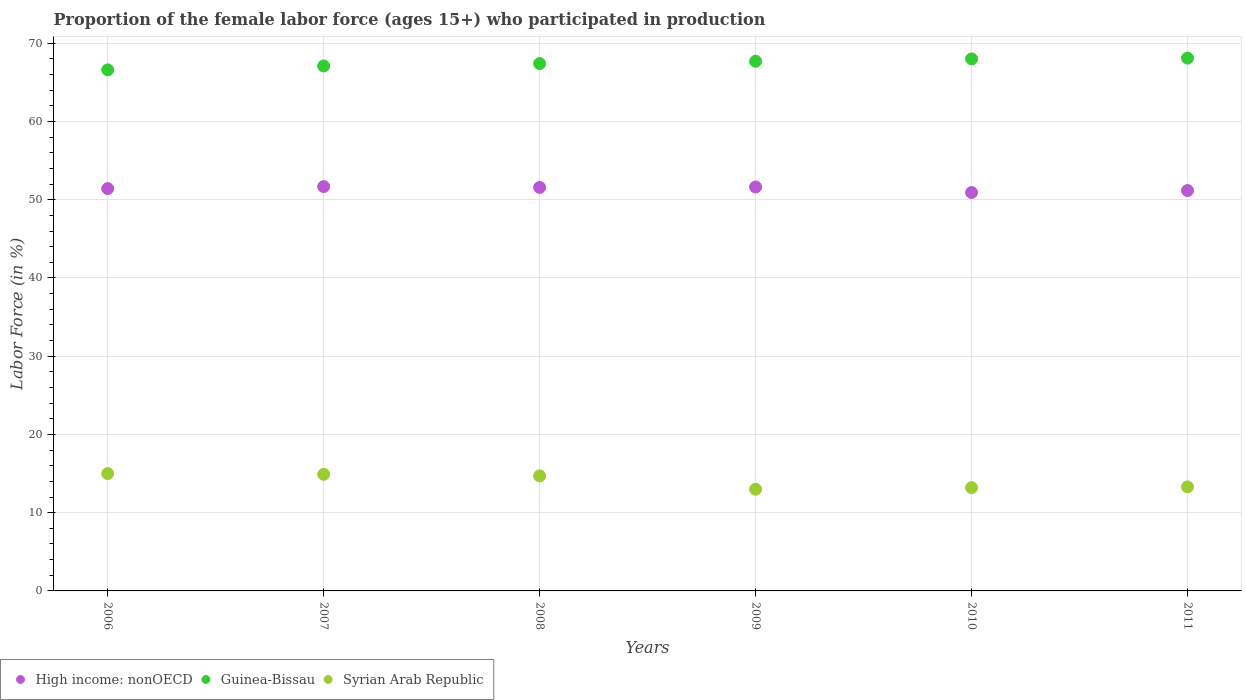Is the number of dotlines equal to the number of legend labels?
Ensure brevity in your answer.  Yes. What is the proportion of the female labor force who participated in production in Syrian Arab Republic in 2011?
Provide a short and direct response. 13.3. Across all years, what is the maximum proportion of the female labor force who participated in production in Syrian Arab Republic?
Give a very brief answer. 15. Across all years, what is the minimum proportion of the female labor force who participated in production in High income: nonOECD?
Offer a terse response. 50.92. In which year was the proportion of the female labor force who participated in production in Syrian Arab Republic maximum?
Your answer should be very brief. 2006. In which year was the proportion of the female labor force who participated in production in Guinea-Bissau minimum?
Give a very brief answer. 2006. What is the total proportion of the female labor force who participated in production in Syrian Arab Republic in the graph?
Your answer should be compact. 84.1. What is the difference between the proportion of the female labor force who participated in production in High income: nonOECD in 2007 and that in 2010?
Provide a succinct answer. 0.76. What is the difference between the proportion of the female labor force who participated in production in Syrian Arab Republic in 2006 and the proportion of the female labor force who participated in production in High income: nonOECD in 2008?
Offer a very short reply. -36.57. What is the average proportion of the female labor force who participated in production in High income: nonOECD per year?
Your answer should be compact. 51.4. In the year 2007, what is the difference between the proportion of the female labor force who participated in production in Guinea-Bissau and proportion of the female labor force who participated in production in Syrian Arab Republic?
Provide a succinct answer. 52.2. What is the ratio of the proportion of the female labor force who participated in production in High income: nonOECD in 2006 to that in 2010?
Keep it short and to the point. 1.01. Is the proportion of the female labor force who participated in production in High income: nonOECD in 2007 less than that in 2011?
Offer a terse response. No. What is the difference between the highest and the second highest proportion of the female labor force who participated in production in High income: nonOECD?
Provide a short and direct response. 0.05. What is the difference between the highest and the lowest proportion of the female labor force who participated in production in Guinea-Bissau?
Ensure brevity in your answer.  1.5. In how many years, is the proportion of the female labor force who participated in production in High income: nonOECD greater than the average proportion of the female labor force who participated in production in High income: nonOECD taken over all years?
Keep it short and to the point. 4. Is the sum of the proportion of the female labor force who participated in production in Syrian Arab Republic in 2008 and 2009 greater than the maximum proportion of the female labor force who participated in production in High income: nonOECD across all years?
Offer a terse response. No. Is it the case that in every year, the sum of the proportion of the female labor force who participated in production in High income: nonOECD and proportion of the female labor force who participated in production in Syrian Arab Republic  is greater than the proportion of the female labor force who participated in production in Guinea-Bissau?
Your answer should be compact. No. Does the proportion of the female labor force who participated in production in High income: nonOECD monotonically increase over the years?
Make the answer very short. No. Is the proportion of the female labor force who participated in production in High income: nonOECD strictly greater than the proportion of the female labor force who participated in production in Guinea-Bissau over the years?
Keep it short and to the point. No. What is the difference between two consecutive major ticks on the Y-axis?
Offer a very short reply. 10. Are the values on the major ticks of Y-axis written in scientific E-notation?
Offer a terse response. No. Where does the legend appear in the graph?
Offer a very short reply. Bottom left. How many legend labels are there?
Provide a succinct answer. 3. What is the title of the graph?
Make the answer very short. Proportion of the female labor force (ages 15+) who participated in production. Does "Botswana" appear as one of the legend labels in the graph?
Give a very brief answer. No. What is the Labor Force (in %) in High income: nonOECD in 2006?
Offer a terse response. 51.42. What is the Labor Force (in %) of Guinea-Bissau in 2006?
Make the answer very short. 66.6. What is the Labor Force (in %) of Syrian Arab Republic in 2006?
Provide a short and direct response. 15. What is the Labor Force (in %) of High income: nonOECD in 2007?
Keep it short and to the point. 51.68. What is the Labor Force (in %) of Guinea-Bissau in 2007?
Keep it short and to the point. 67.1. What is the Labor Force (in %) of Syrian Arab Republic in 2007?
Ensure brevity in your answer.  14.9. What is the Labor Force (in %) of High income: nonOECD in 2008?
Keep it short and to the point. 51.57. What is the Labor Force (in %) in Guinea-Bissau in 2008?
Ensure brevity in your answer.  67.4. What is the Labor Force (in %) of Syrian Arab Republic in 2008?
Provide a short and direct response. 14.7. What is the Labor Force (in %) in High income: nonOECD in 2009?
Your answer should be very brief. 51.63. What is the Labor Force (in %) of Guinea-Bissau in 2009?
Provide a short and direct response. 67.7. What is the Labor Force (in %) of High income: nonOECD in 2010?
Your answer should be compact. 50.92. What is the Labor Force (in %) in Guinea-Bissau in 2010?
Make the answer very short. 68. What is the Labor Force (in %) of Syrian Arab Republic in 2010?
Provide a short and direct response. 13.2. What is the Labor Force (in %) of High income: nonOECD in 2011?
Your response must be concise. 51.18. What is the Labor Force (in %) of Guinea-Bissau in 2011?
Make the answer very short. 68.1. What is the Labor Force (in %) in Syrian Arab Republic in 2011?
Offer a terse response. 13.3. Across all years, what is the maximum Labor Force (in %) of High income: nonOECD?
Ensure brevity in your answer.  51.68. Across all years, what is the maximum Labor Force (in %) of Guinea-Bissau?
Your response must be concise. 68.1. Across all years, what is the maximum Labor Force (in %) in Syrian Arab Republic?
Offer a terse response. 15. Across all years, what is the minimum Labor Force (in %) of High income: nonOECD?
Provide a short and direct response. 50.92. Across all years, what is the minimum Labor Force (in %) in Guinea-Bissau?
Your response must be concise. 66.6. Across all years, what is the minimum Labor Force (in %) in Syrian Arab Republic?
Keep it short and to the point. 13. What is the total Labor Force (in %) in High income: nonOECD in the graph?
Offer a very short reply. 308.4. What is the total Labor Force (in %) of Guinea-Bissau in the graph?
Provide a succinct answer. 404.9. What is the total Labor Force (in %) of Syrian Arab Republic in the graph?
Ensure brevity in your answer.  84.1. What is the difference between the Labor Force (in %) in High income: nonOECD in 2006 and that in 2007?
Give a very brief answer. -0.26. What is the difference between the Labor Force (in %) of Guinea-Bissau in 2006 and that in 2007?
Keep it short and to the point. -0.5. What is the difference between the Labor Force (in %) in High income: nonOECD in 2006 and that in 2008?
Give a very brief answer. -0.15. What is the difference between the Labor Force (in %) of Syrian Arab Republic in 2006 and that in 2008?
Provide a succinct answer. 0.3. What is the difference between the Labor Force (in %) of High income: nonOECD in 2006 and that in 2009?
Ensure brevity in your answer.  -0.2. What is the difference between the Labor Force (in %) in Syrian Arab Republic in 2006 and that in 2009?
Keep it short and to the point. 2. What is the difference between the Labor Force (in %) in High income: nonOECD in 2006 and that in 2010?
Offer a terse response. 0.5. What is the difference between the Labor Force (in %) of Syrian Arab Republic in 2006 and that in 2010?
Give a very brief answer. 1.8. What is the difference between the Labor Force (in %) in High income: nonOECD in 2006 and that in 2011?
Your response must be concise. 0.25. What is the difference between the Labor Force (in %) of Guinea-Bissau in 2006 and that in 2011?
Your answer should be very brief. -1.5. What is the difference between the Labor Force (in %) of Syrian Arab Republic in 2006 and that in 2011?
Offer a terse response. 1.7. What is the difference between the Labor Force (in %) in High income: nonOECD in 2007 and that in 2008?
Offer a very short reply. 0.11. What is the difference between the Labor Force (in %) of Guinea-Bissau in 2007 and that in 2008?
Give a very brief answer. -0.3. What is the difference between the Labor Force (in %) in High income: nonOECD in 2007 and that in 2009?
Your answer should be very brief. 0.05. What is the difference between the Labor Force (in %) in High income: nonOECD in 2007 and that in 2010?
Offer a terse response. 0.76. What is the difference between the Labor Force (in %) in High income: nonOECD in 2007 and that in 2011?
Give a very brief answer. 0.5. What is the difference between the Labor Force (in %) of High income: nonOECD in 2008 and that in 2009?
Provide a short and direct response. -0.06. What is the difference between the Labor Force (in %) of Syrian Arab Republic in 2008 and that in 2009?
Keep it short and to the point. 1.7. What is the difference between the Labor Force (in %) of High income: nonOECD in 2008 and that in 2010?
Offer a terse response. 0.65. What is the difference between the Labor Force (in %) in Syrian Arab Republic in 2008 and that in 2010?
Provide a short and direct response. 1.5. What is the difference between the Labor Force (in %) in High income: nonOECD in 2008 and that in 2011?
Your answer should be very brief. 0.4. What is the difference between the Labor Force (in %) in Syrian Arab Republic in 2008 and that in 2011?
Provide a short and direct response. 1.4. What is the difference between the Labor Force (in %) of High income: nonOECD in 2009 and that in 2010?
Provide a short and direct response. 0.71. What is the difference between the Labor Force (in %) of Guinea-Bissau in 2009 and that in 2010?
Provide a short and direct response. -0.3. What is the difference between the Labor Force (in %) in Syrian Arab Republic in 2009 and that in 2010?
Ensure brevity in your answer.  -0.2. What is the difference between the Labor Force (in %) of High income: nonOECD in 2009 and that in 2011?
Give a very brief answer. 0.45. What is the difference between the Labor Force (in %) in Syrian Arab Republic in 2009 and that in 2011?
Your response must be concise. -0.3. What is the difference between the Labor Force (in %) of High income: nonOECD in 2010 and that in 2011?
Ensure brevity in your answer.  -0.25. What is the difference between the Labor Force (in %) of Guinea-Bissau in 2010 and that in 2011?
Offer a very short reply. -0.1. What is the difference between the Labor Force (in %) of Syrian Arab Republic in 2010 and that in 2011?
Make the answer very short. -0.1. What is the difference between the Labor Force (in %) of High income: nonOECD in 2006 and the Labor Force (in %) of Guinea-Bissau in 2007?
Provide a short and direct response. -15.68. What is the difference between the Labor Force (in %) of High income: nonOECD in 2006 and the Labor Force (in %) of Syrian Arab Republic in 2007?
Keep it short and to the point. 36.52. What is the difference between the Labor Force (in %) in Guinea-Bissau in 2006 and the Labor Force (in %) in Syrian Arab Republic in 2007?
Offer a terse response. 51.7. What is the difference between the Labor Force (in %) of High income: nonOECD in 2006 and the Labor Force (in %) of Guinea-Bissau in 2008?
Your answer should be very brief. -15.98. What is the difference between the Labor Force (in %) in High income: nonOECD in 2006 and the Labor Force (in %) in Syrian Arab Republic in 2008?
Your answer should be compact. 36.72. What is the difference between the Labor Force (in %) of Guinea-Bissau in 2006 and the Labor Force (in %) of Syrian Arab Republic in 2008?
Your response must be concise. 51.9. What is the difference between the Labor Force (in %) of High income: nonOECD in 2006 and the Labor Force (in %) of Guinea-Bissau in 2009?
Ensure brevity in your answer.  -16.28. What is the difference between the Labor Force (in %) in High income: nonOECD in 2006 and the Labor Force (in %) in Syrian Arab Republic in 2009?
Make the answer very short. 38.42. What is the difference between the Labor Force (in %) in Guinea-Bissau in 2006 and the Labor Force (in %) in Syrian Arab Republic in 2009?
Provide a succinct answer. 53.6. What is the difference between the Labor Force (in %) of High income: nonOECD in 2006 and the Labor Force (in %) of Guinea-Bissau in 2010?
Your response must be concise. -16.58. What is the difference between the Labor Force (in %) in High income: nonOECD in 2006 and the Labor Force (in %) in Syrian Arab Republic in 2010?
Give a very brief answer. 38.22. What is the difference between the Labor Force (in %) in Guinea-Bissau in 2006 and the Labor Force (in %) in Syrian Arab Republic in 2010?
Offer a terse response. 53.4. What is the difference between the Labor Force (in %) of High income: nonOECD in 2006 and the Labor Force (in %) of Guinea-Bissau in 2011?
Ensure brevity in your answer.  -16.68. What is the difference between the Labor Force (in %) of High income: nonOECD in 2006 and the Labor Force (in %) of Syrian Arab Republic in 2011?
Make the answer very short. 38.12. What is the difference between the Labor Force (in %) in Guinea-Bissau in 2006 and the Labor Force (in %) in Syrian Arab Republic in 2011?
Your response must be concise. 53.3. What is the difference between the Labor Force (in %) in High income: nonOECD in 2007 and the Labor Force (in %) in Guinea-Bissau in 2008?
Your answer should be very brief. -15.72. What is the difference between the Labor Force (in %) in High income: nonOECD in 2007 and the Labor Force (in %) in Syrian Arab Republic in 2008?
Your response must be concise. 36.98. What is the difference between the Labor Force (in %) in Guinea-Bissau in 2007 and the Labor Force (in %) in Syrian Arab Republic in 2008?
Your response must be concise. 52.4. What is the difference between the Labor Force (in %) in High income: nonOECD in 2007 and the Labor Force (in %) in Guinea-Bissau in 2009?
Your answer should be very brief. -16.02. What is the difference between the Labor Force (in %) of High income: nonOECD in 2007 and the Labor Force (in %) of Syrian Arab Republic in 2009?
Offer a terse response. 38.68. What is the difference between the Labor Force (in %) of Guinea-Bissau in 2007 and the Labor Force (in %) of Syrian Arab Republic in 2009?
Make the answer very short. 54.1. What is the difference between the Labor Force (in %) in High income: nonOECD in 2007 and the Labor Force (in %) in Guinea-Bissau in 2010?
Provide a succinct answer. -16.32. What is the difference between the Labor Force (in %) of High income: nonOECD in 2007 and the Labor Force (in %) of Syrian Arab Republic in 2010?
Your answer should be very brief. 38.48. What is the difference between the Labor Force (in %) of Guinea-Bissau in 2007 and the Labor Force (in %) of Syrian Arab Republic in 2010?
Ensure brevity in your answer.  53.9. What is the difference between the Labor Force (in %) in High income: nonOECD in 2007 and the Labor Force (in %) in Guinea-Bissau in 2011?
Provide a short and direct response. -16.42. What is the difference between the Labor Force (in %) of High income: nonOECD in 2007 and the Labor Force (in %) of Syrian Arab Republic in 2011?
Your response must be concise. 38.38. What is the difference between the Labor Force (in %) of Guinea-Bissau in 2007 and the Labor Force (in %) of Syrian Arab Republic in 2011?
Your answer should be compact. 53.8. What is the difference between the Labor Force (in %) in High income: nonOECD in 2008 and the Labor Force (in %) in Guinea-Bissau in 2009?
Your response must be concise. -16.13. What is the difference between the Labor Force (in %) of High income: nonOECD in 2008 and the Labor Force (in %) of Syrian Arab Republic in 2009?
Provide a short and direct response. 38.57. What is the difference between the Labor Force (in %) of Guinea-Bissau in 2008 and the Labor Force (in %) of Syrian Arab Republic in 2009?
Provide a succinct answer. 54.4. What is the difference between the Labor Force (in %) of High income: nonOECD in 2008 and the Labor Force (in %) of Guinea-Bissau in 2010?
Offer a very short reply. -16.43. What is the difference between the Labor Force (in %) of High income: nonOECD in 2008 and the Labor Force (in %) of Syrian Arab Republic in 2010?
Give a very brief answer. 38.37. What is the difference between the Labor Force (in %) of Guinea-Bissau in 2008 and the Labor Force (in %) of Syrian Arab Republic in 2010?
Your answer should be compact. 54.2. What is the difference between the Labor Force (in %) of High income: nonOECD in 2008 and the Labor Force (in %) of Guinea-Bissau in 2011?
Make the answer very short. -16.53. What is the difference between the Labor Force (in %) of High income: nonOECD in 2008 and the Labor Force (in %) of Syrian Arab Republic in 2011?
Offer a terse response. 38.27. What is the difference between the Labor Force (in %) in Guinea-Bissau in 2008 and the Labor Force (in %) in Syrian Arab Republic in 2011?
Offer a terse response. 54.1. What is the difference between the Labor Force (in %) of High income: nonOECD in 2009 and the Labor Force (in %) of Guinea-Bissau in 2010?
Ensure brevity in your answer.  -16.37. What is the difference between the Labor Force (in %) of High income: nonOECD in 2009 and the Labor Force (in %) of Syrian Arab Republic in 2010?
Your answer should be compact. 38.43. What is the difference between the Labor Force (in %) in Guinea-Bissau in 2009 and the Labor Force (in %) in Syrian Arab Republic in 2010?
Your response must be concise. 54.5. What is the difference between the Labor Force (in %) in High income: nonOECD in 2009 and the Labor Force (in %) in Guinea-Bissau in 2011?
Give a very brief answer. -16.47. What is the difference between the Labor Force (in %) in High income: nonOECD in 2009 and the Labor Force (in %) in Syrian Arab Republic in 2011?
Make the answer very short. 38.33. What is the difference between the Labor Force (in %) in Guinea-Bissau in 2009 and the Labor Force (in %) in Syrian Arab Republic in 2011?
Your answer should be very brief. 54.4. What is the difference between the Labor Force (in %) of High income: nonOECD in 2010 and the Labor Force (in %) of Guinea-Bissau in 2011?
Offer a terse response. -17.18. What is the difference between the Labor Force (in %) in High income: nonOECD in 2010 and the Labor Force (in %) in Syrian Arab Republic in 2011?
Ensure brevity in your answer.  37.62. What is the difference between the Labor Force (in %) of Guinea-Bissau in 2010 and the Labor Force (in %) of Syrian Arab Republic in 2011?
Provide a succinct answer. 54.7. What is the average Labor Force (in %) in High income: nonOECD per year?
Make the answer very short. 51.4. What is the average Labor Force (in %) of Guinea-Bissau per year?
Your response must be concise. 67.48. What is the average Labor Force (in %) of Syrian Arab Republic per year?
Your response must be concise. 14.02. In the year 2006, what is the difference between the Labor Force (in %) of High income: nonOECD and Labor Force (in %) of Guinea-Bissau?
Your answer should be compact. -15.18. In the year 2006, what is the difference between the Labor Force (in %) of High income: nonOECD and Labor Force (in %) of Syrian Arab Republic?
Make the answer very short. 36.42. In the year 2006, what is the difference between the Labor Force (in %) in Guinea-Bissau and Labor Force (in %) in Syrian Arab Republic?
Your response must be concise. 51.6. In the year 2007, what is the difference between the Labor Force (in %) in High income: nonOECD and Labor Force (in %) in Guinea-Bissau?
Give a very brief answer. -15.42. In the year 2007, what is the difference between the Labor Force (in %) of High income: nonOECD and Labor Force (in %) of Syrian Arab Republic?
Your response must be concise. 36.78. In the year 2007, what is the difference between the Labor Force (in %) in Guinea-Bissau and Labor Force (in %) in Syrian Arab Republic?
Your answer should be compact. 52.2. In the year 2008, what is the difference between the Labor Force (in %) in High income: nonOECD and Labor Force (in %) in Guinea-Bissau?
Keep it short and to the point. -15.83. In the year 2008, what is the difference between the Labor Force (in %) in High income: nonOECD and Labor Force (in %) in Syrian Arab Republic?
Offer a terse response. 36.87. In the year 2008, what is the difference between the Labor Force (in %) in Guinea-Bissau and Labor Force (in %) in Syrian Arab Republic?
Keep it short and to the point. 52.7. In the year 2009, what is the difference between the Labor Force (in %) in High income: nonOECD and Labor Force (in %) in Guinea-Bissau?
Offer a very short reply. -16.07. In the year 2009, what is the difference between the Labor Force (in %) in High income: nonOECD and Labor Force (in %) in Syrian Arab Republic?
Provide a succinct answer. 38.63. In the year 2009, what is the difference between the Labor Force (in %) of Guinea-Bissau and Labor Force (in %) of Syrian Arab Republic?
Your answer should be very brief. 54.7. In the year 2010, what is the difference between the Labor Force (in %) in High income: nonOECD and Labor Force (in %) in Guinea-Bissau?
Offer a terse response. -17.08. In the year 2010, what is the difference between the Labor Force (in %) in High income: nonOECD and Labor Force (in %) in Syrian Arab Republic?
Your answer should be compact. 37.72. In the year 2010, what is the difference between the Labor Force (in %) of Guinea-Bissau and Labor Force (in %) of Syrian Arab Republic?
Your answer should be very brief. 54.8. In the year 2011, what is the difference between the Labor Force (in %) of High income: nonOECD and Labor Force (in %) of Guinea-Bissau?
Make the answer very short. -16.92. In the year 2011, what is the difference between the Labor Force (in %) of High income: nonOECD and Labor Force (in %) of Syrian Arab Republic?
Offer a terse response. 37.88. In the year 2011, what is the difference between the Labor Force (in %) of Guinea-Bissau and Labor Force (in %) of Syrian Arab Republic?
Your response must be concise. 54.8. What is the ratio of the Labor Force (in %) in Guinea-Bissau in 2006 to that in 2007?
Offer a terse response. 0.99. What is the ratio of the Labor Force (in %) in Syrian Arab Republic in 2006 to that in 2007?
Your answer should be very brief. 1.01. What is the ratio of the Labor Force (in %) in Syrian Arab Republic in 2006 to that in 2008?
Make the answer very short. 1.02. What is the ratio of the Labor Force (in %) in High income: nonOECD in 2006 to that in 2009?
Ensure brevity in your answer.  1. What is the ratio of the Labor Force (in %) in Guinea-Bissau in 2006 to that in 2009?
Your answer should be very brief. 0.98. What is the ratio of the Labor Force (in %) of Syrian Arab Republic in 2006 to that in 2009?
Provide a succinct answer. 1.15. What is the ratio of the Labor Force (in %) in High income: nonOECD in 2006 to that in 2010?
Make the answer very short. 1.01. What is the ratio of the Labor Force (in %) in Guinea-Bissau in 2006 to that in 2010?
Ensure brevity in your answer.  0.98. What is the ratio of the Labor Force (in %) in Syrian Arab Republic in 2006 to that in 2010?
Make the answer very short. 1.14. What is the ratio of the Labor Force (in %) of Guinea-Bissau in 2006 to that in 2011?
Provide a succinct answer. 0.98. What is the ratio of the Labor Force (in %) in Syrian Arab Republic in 2006 to that in 2011?
Ensure brevity in your answer.  1.13. What is the ratio of the Labor Force (in %) in High income: nonOECD in 2007 to that in 2008?
Keep it short and to the point. 1. What is the ratio of the Labor Force (in %) of Guinea-Bissau in 2007 to that in 2008?
Offer a terse response. 1. What is the ratio of the Labor Force (in %) in Syrian Arab Republic in 2007 to that in 2008?
Ensure brevity in your answer.  1.01. What is the ratio of the Labor Force (in %) in Syrian Arab Republic in 2007 to that in 2009?
Make the answer very short. 1.15. What is the ratio of the Labor Force (in %) of High income: nonOECD in 2007 to that in 2010?
Offer a terse response. 1.01. What is the ratio of the Labor Force (in %) of Guinea-Bissau in 2007 to that in 2010?
Offer a terse response. 0.99. What is the ratio of the Labor Force (in %) of Syrian Arab Republic in 2007 to that in 2010?
Give a very brief answer. 1.13. What is the ratio of the Labor Force (in %) of High income: nonOECD in 2007 to that in 2011?
Provide a short and direct response. 1.01. What is the ratio of the Labor Force (in %) of Guinea-Bissau in 2007 to that in 2011?
Ensure brevity in your answer.  0.99. What is the ratio of the Labor Force (in %) in Syrian Arab Republic in 2007 to that in 2011?
Offer a terse response. 1.12. What is the ratio of the Labor Force (in %) of Guinea-Bissau in 2008 to that in 2009?
Your answer should be very brief. 1. What is the ratio of the Labor Force (in %) of Syrian Arab Republic in 2008 to that in 2009?
Make the answer very short. 1.13. What is the ratio of the Labor Force (in %) in High income: nonOECD in 2008 to that in 2010?
Give a very brief answer. 1.01. What is the ratio of the Labor Force (in %) of Guinea-Bissau in 2008 to that in 2010?
Your answer should be very brief. 0.99. What is the ratio of the Labor Force (in %) of Syrian Arab Republic in 2008 to that in 2010?
Your response must be concise. 1.11. What is the ratio of the Labor Force (in %) in High income: nonOECD in 2008 to that in 2011?
Your response must be concise. 1.01. What is the ratio of the Labor Force (in %) of Guinea-Bissau in 2008 to that in 2011?
Provide a succinct answer. 0.99. What is the ratio of the Labor Force (in %) in Syrian Arab Republic in 2008 to that in 2011?
Offer a terse response. 1.11. What is the ratio of the Labor Force (in %) in High income: nonOECD in 2009 to that in 2010?
Offer a terse response. 1.01. What is the ratio of the Labor Force (in %) of Syrian Arab Republic in 2009 to that in 2010?
Your answer should be very brief. 0.98. What is the ratio of the Labor Force (in %) of High income: nonOECD in 2009 to that in 2011?
Offer a very short reply. 1.01. What is the ratio of the Labor Force (in %) of Guinea-Bissau in 2009 to that in 2011?
Provide a short and direct response. 0.99. What is the ratio of the Labor Force (in %) of Syrian Arab Republic in 2009 to that in 2011?
Make the answer very short. 0.98. What is the ratio of the Labor Force (in %) in Guinea-Bissau in 2010 to that in 2011?
Make the answer very short. 1. What is the difference between the highest and the second highest Labor Force (in %) in High income: nonOECD?
Ensure brevity in your answer.  0.05. What is the difference between the highest and the lowest Labor Force (in %) of High income: nonOECD?
Offer a very short reply. 0.76. What is the difference between the highest and the lowest Labor Force (in %) of Syrian Arab Republic?
Provide a succinct answer. 2. 